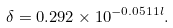Convert formula to latex. <formula><loc_0><loc_0><loc_500><loc_500>\delta = 0 . 2 9 2 \times 1 0 ^ { - 0 . 0 5 1 1 l } .</formula> 